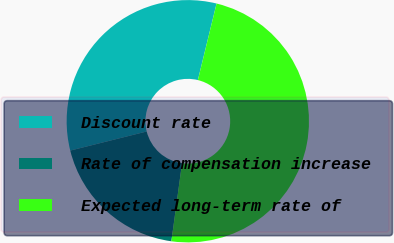Convert chart. <chart><loc_0><loc_0><loc_500><loc_500><pie_chart><fcel>Discount rate<fcel>Rate of compensation increase<fcel>Expected long-term rate of<nl><fcel>32.71%<fcel>18.94%<fcel>48.35%<nl></chart> 